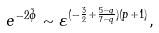<formula> <loc_0><loc_0><loc_500><loc_500>e ^ { - 2 \tilde { \phi } } \sim \varepsilon ^ { ( - \frac { 3 } { 2 } + \frac { 5 - q } { 7 - q } ) ( p + 1 ) } ,</formula> 